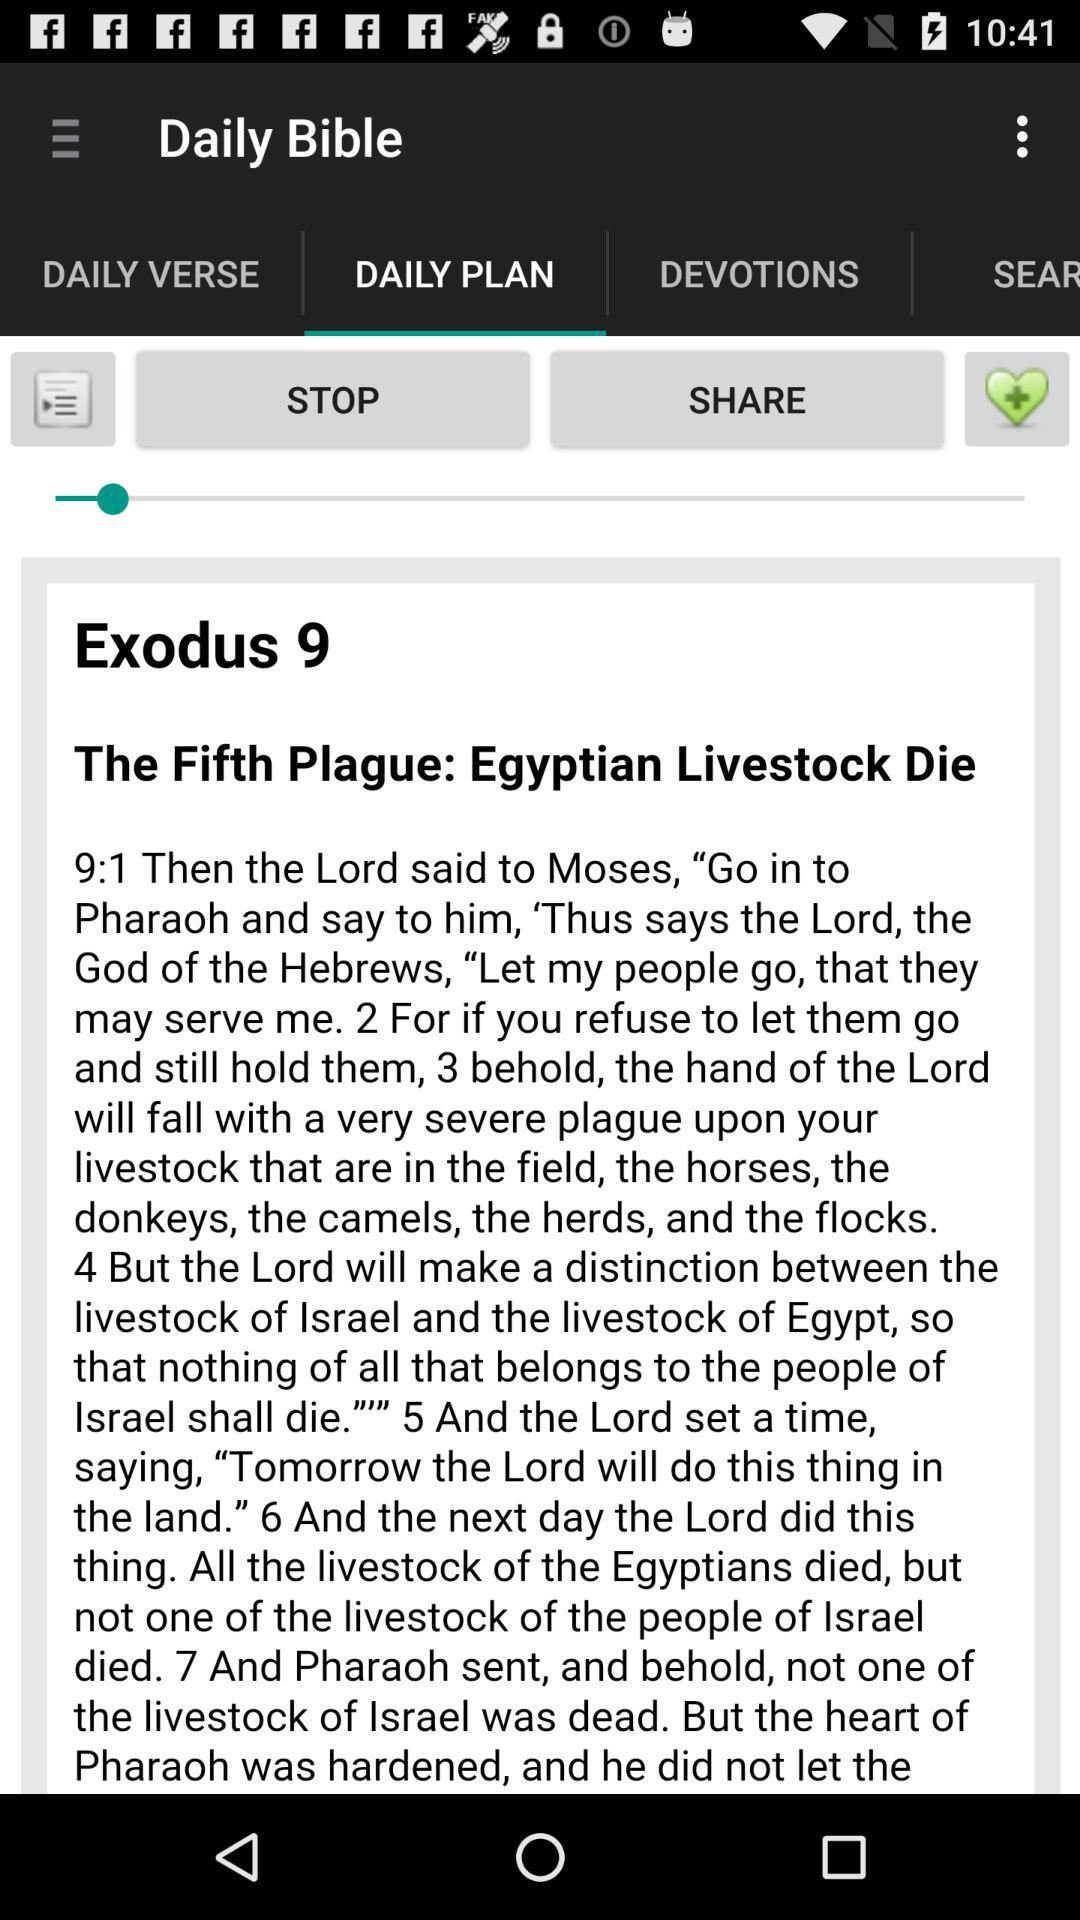What is the application name? The application name is "Daily Bible". 